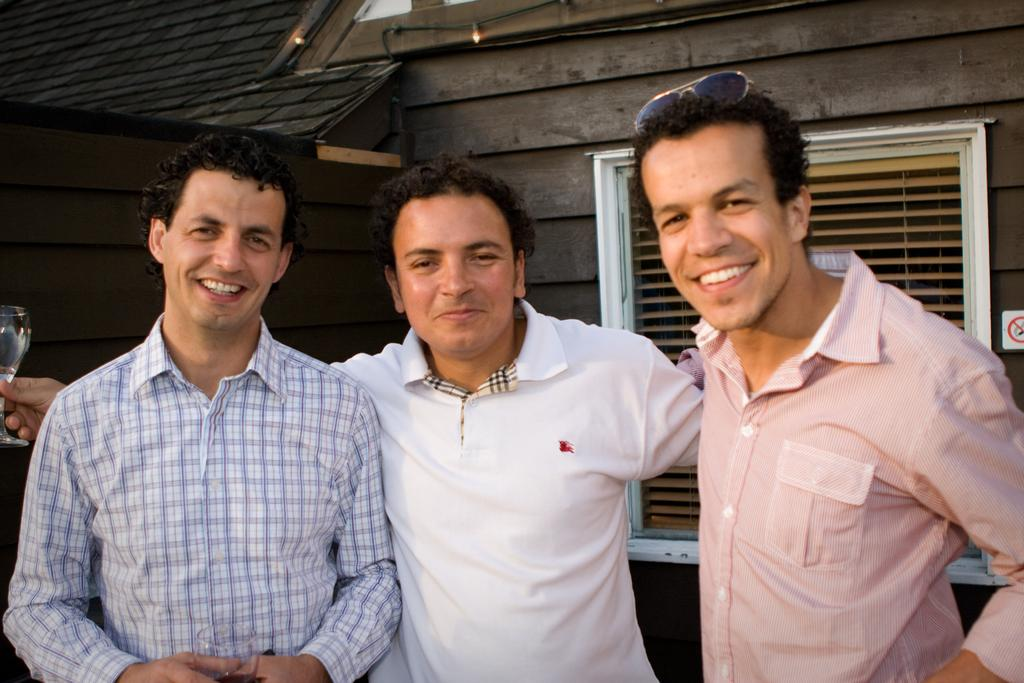How many people are in the image? There are three persons standing and smiling in the image. What are the people holding in the image? There is a person holding a wine glass in the image. What can be seen in the background of the image? There is a window shutter on the wall in the background of the image. What is the general mood or expression of the people in the image? The people are standing and smiling, which suggests a positive or happy mood. What type of toy is being twisted by the person in the image? There is no toy present in the image, nor is anyone twisting anything. 